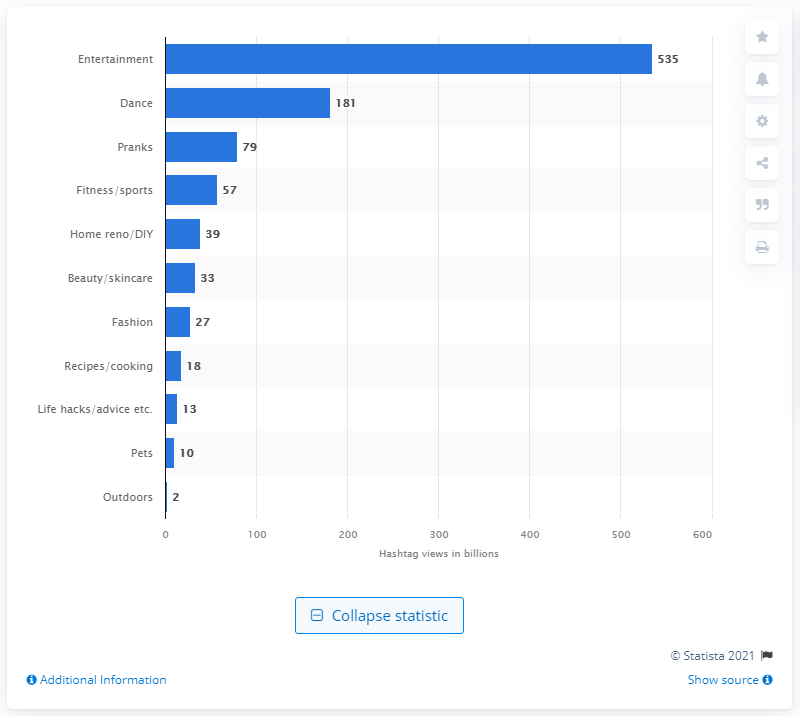Mention a couple of crucial points in this snapshot. According to the given information, entertainment content on TikTok has received 535 hashtag views. 